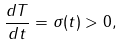<formula> <loc_0><loc_0><loc_500><loc_500>\frac { d T } { d t } = \sigma ( t ) > 0 ,</formula> 